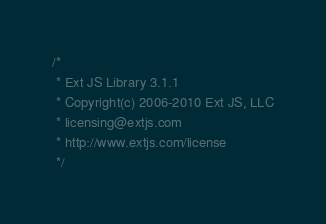Convert code to text. <code><loc_0><loc_0><loc_500><loc_500><_JavaScript_>/*
 * Ext JS Library 3.1.1
 * Copyright(c) 2006-2010 Ext JS, LLC
 * licensing@extjs.com
 * http://www.extjs.com/license
 */</code> 